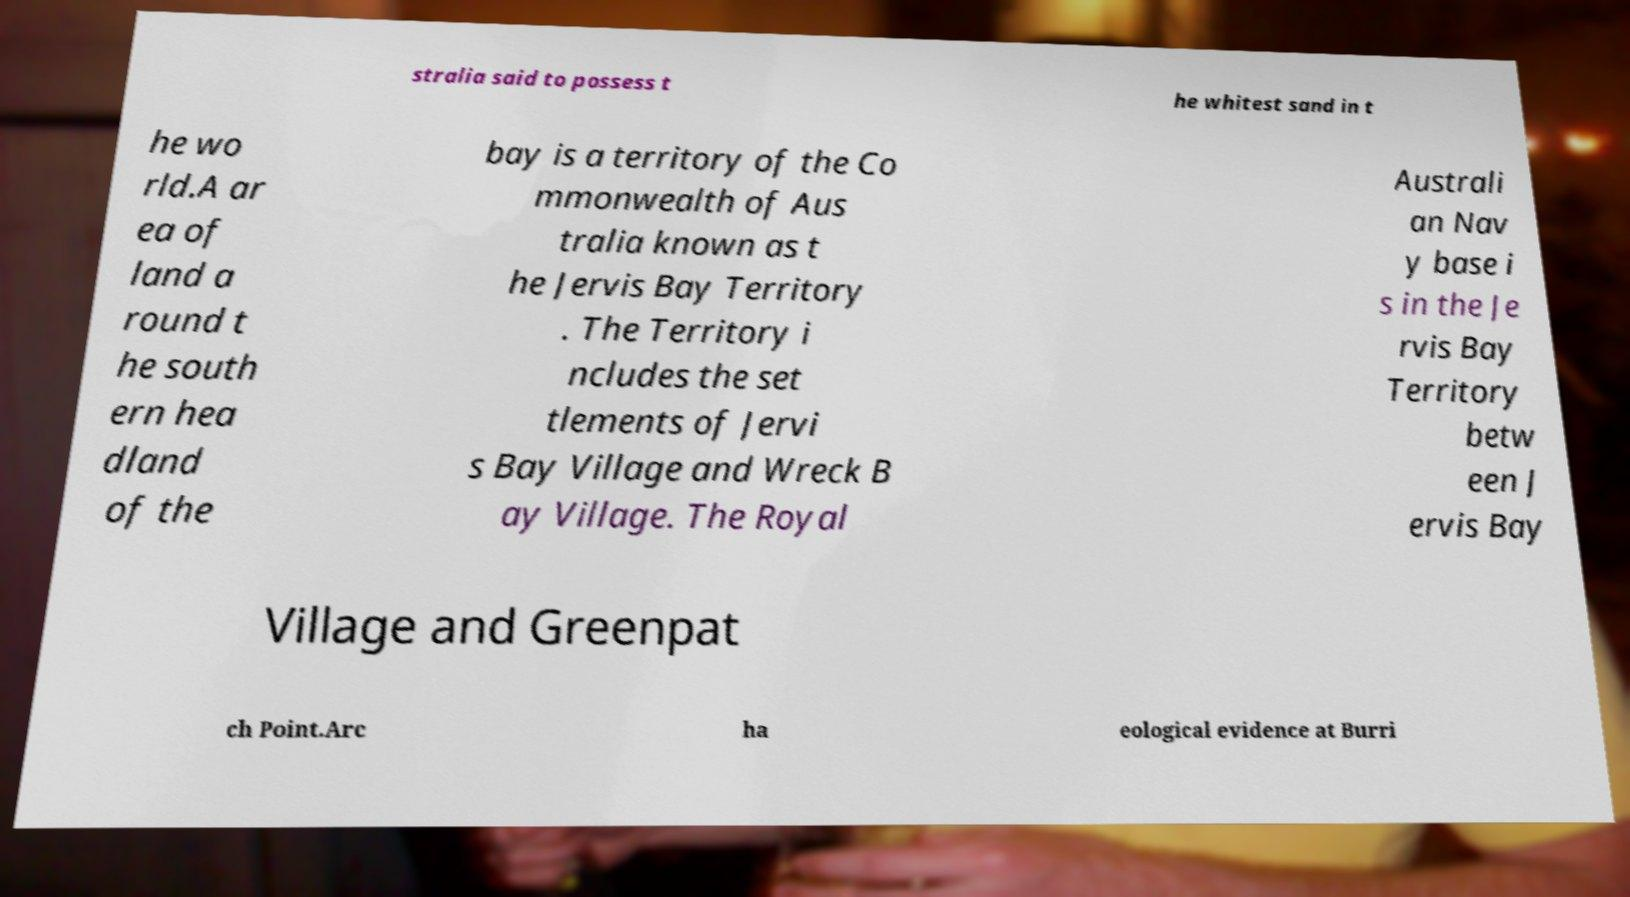Can you read and provide the text displayed in the image?This photo seems to have some interesting text. Can you extract and type it out for me? stralia said to possess t he whitest sand in t he wo rld.A ar ea of land a round t he south ern hea dland of the bay is a territory of the Co mmonwealth of Aus tralia known as t he Jervis Bay Territory . The Territory i ncludes the set tlements of Jervi s Bay Village and Wreck B ay Village. The Royal Australi an Nav y base i s in the Je rvis Bay Territory betw een J ervis Bay Village and Greenpat ch Point.Arc ha eological evidence at Burri 